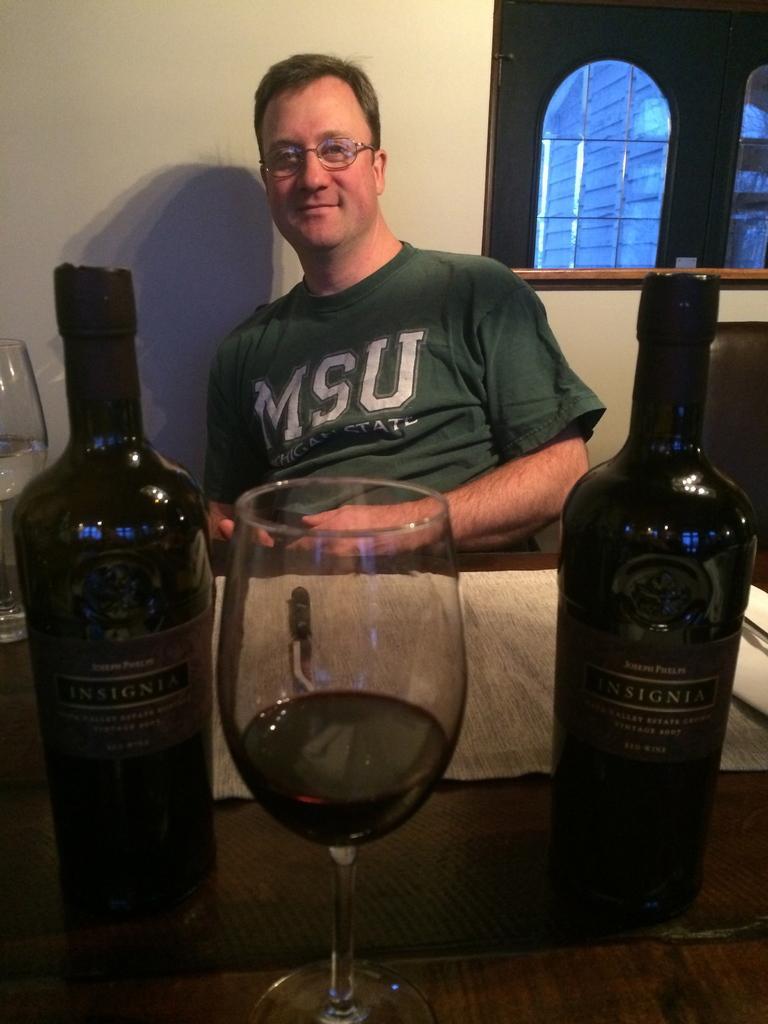How would you summarize this image in a sentence or two? In this age I can see the person wearing the green color t-shirt and specs. In-front of the person I can see the table. On the table there are wine bottles and glasses. In the back I can see the wall and the window. 